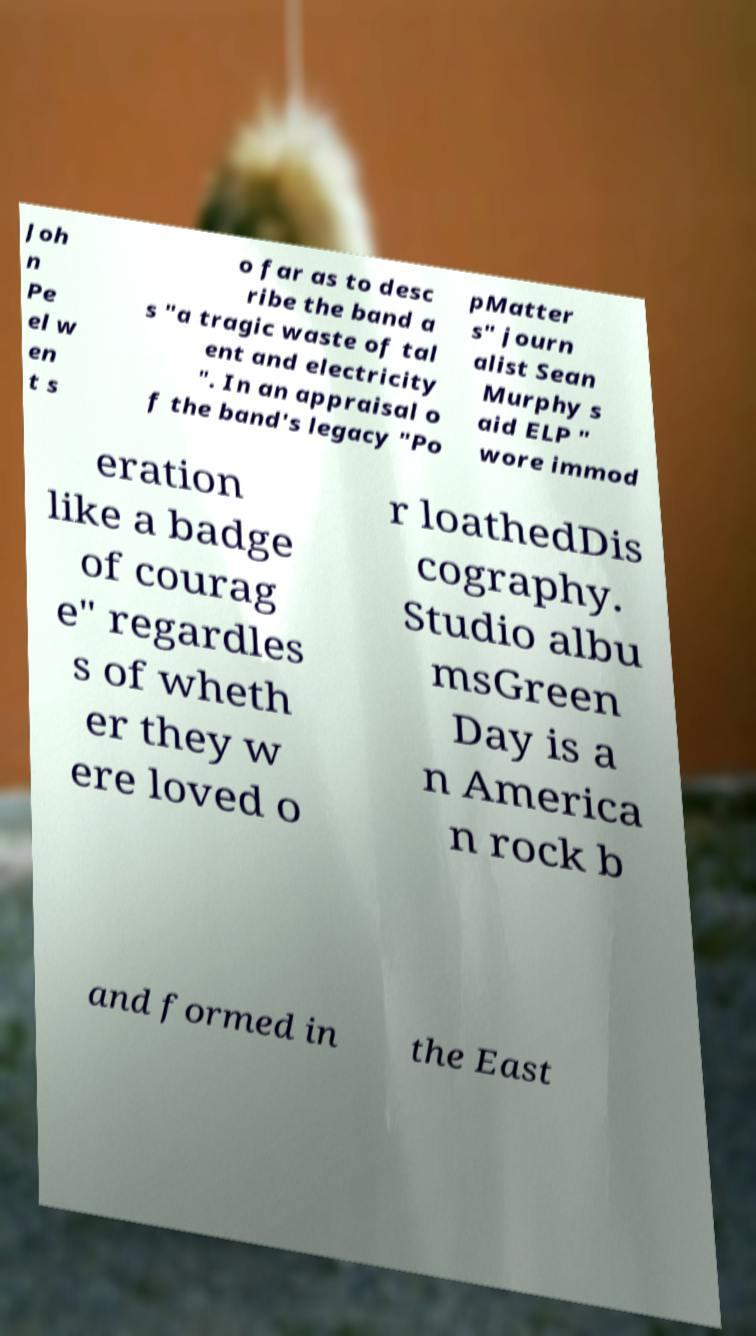Could you assist in decoding the text presented in this image and type it out clearly? Joh n Pe el w en t s o far as to desc ribe the band a s "a tragic waste of tal ent and electricity ". In an appraisal o f the band's legacy "Po pMatter s" journ alist Sean Murphy s aid ELP " wore immod eration like a badge of courag e" regardles s of wheth er they w ere loved o r loathedDis cography. Studio albu msGreen Day is a n America n rock b and formed in the East 